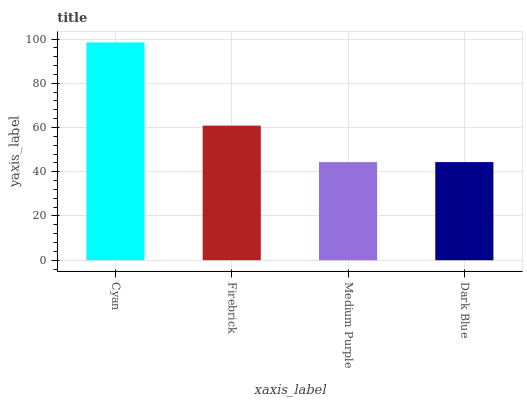Is Medium Purple the minimum?
Answer yes or no. Yes. Is Cyan the maximum?
Answer yes or no. Yes. Is Firebrick the minimum?
Answer yes or no. No. Is Firebrick the maximum?
Answer yes or no. No. Is Cyan greater than Firebrick?
Answer yes or no. Yes. Is Firebrick less than Cyan?
Answer yes or no. Yes. Is Firebrick greater than Cyan?
Answer yes or no. No. Is Cyan less than Firebrick?
Answer yes or no. No. Is Firebrick the high median?
Answer yes or no. Yes. Is Dark Blue the low median?
Answer yes or no. Yes. Is Cyan the high median?
Answer yes or no. No. Is Cyan the low median?
Answer yes or no. No. 